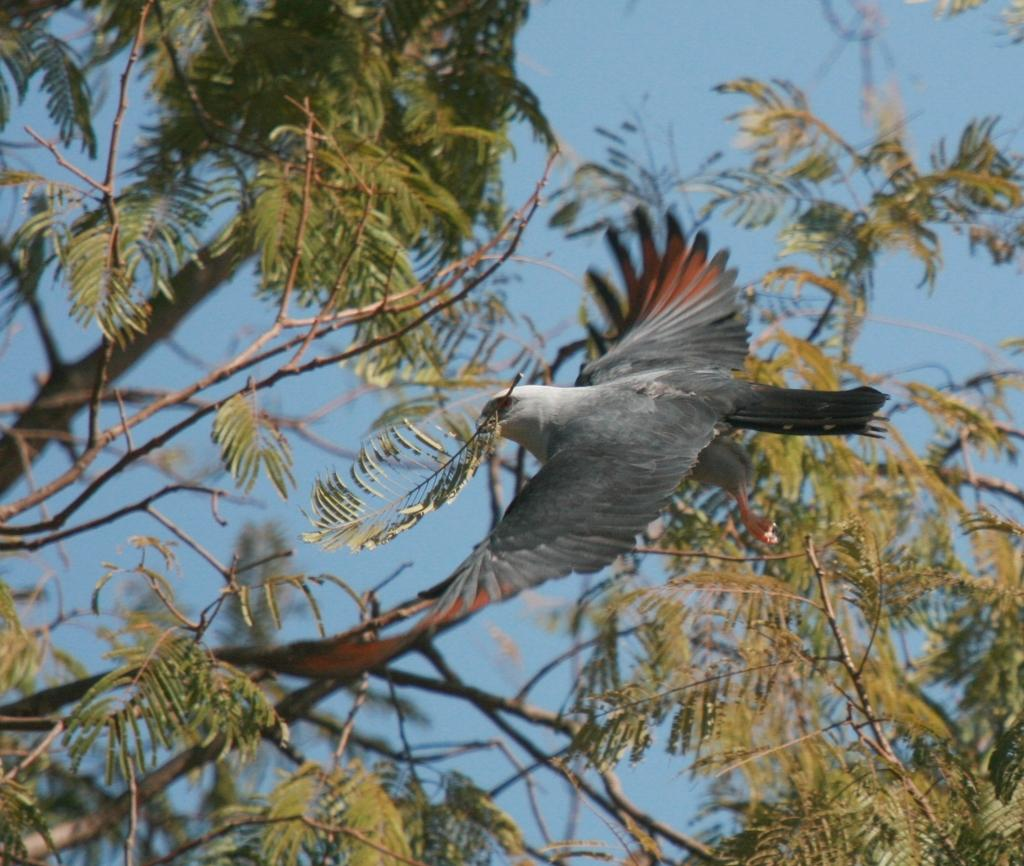What type of animal can be seen in the image? There is a bird in the image. What is the bird doing in the image? The bird is flying. What is the bird holding in its beak? The bird is holding a leaf in its beak. What color is the bird in the image? The bird is grey in color. What can be seen on the left side of the image? There are trees on the left side of the image. What is visible at the top of the image? The sky is visible at the top of the image. How many quarters can be seen in the image? There are no quarters present in the image. What type of fruit is the bird holding in its beak? The bird is not holding a fruit in its beak; it is holding a leaf. 